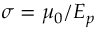Convert formula to latex. <formula><loc_0><loc_0><loc_500><loc_500>\sigma = \mu _ { 0 } / E _ { p }</formula> 